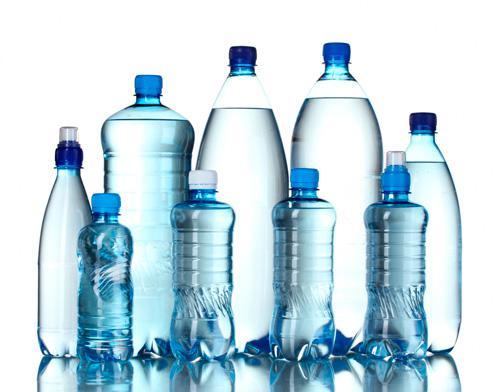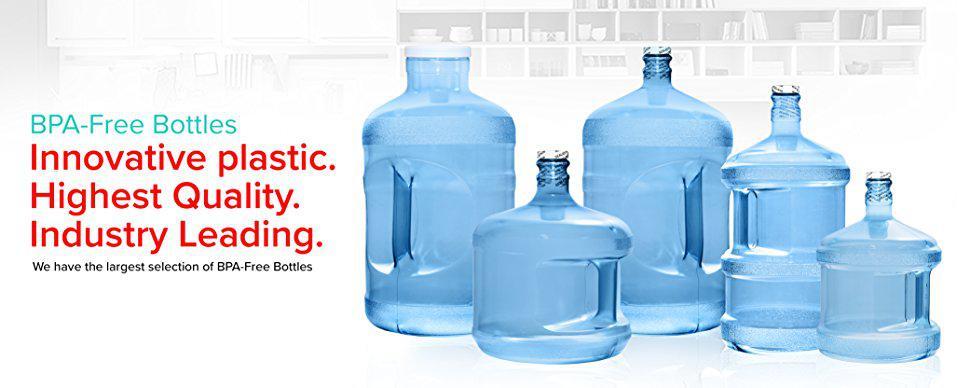The first image is the image on the left, the second image is the image on the right. For the images shown, is this caption "In the image on the left, all of the bottle are the same size." true? Answer yes or no. No. The first image is the image on the left, the second image is the image on the right. Given the left and right images, does the statement "Each image shows at least five water bottles arranged in an overlapping formation." hold true? Answer yes or no. Yes. 